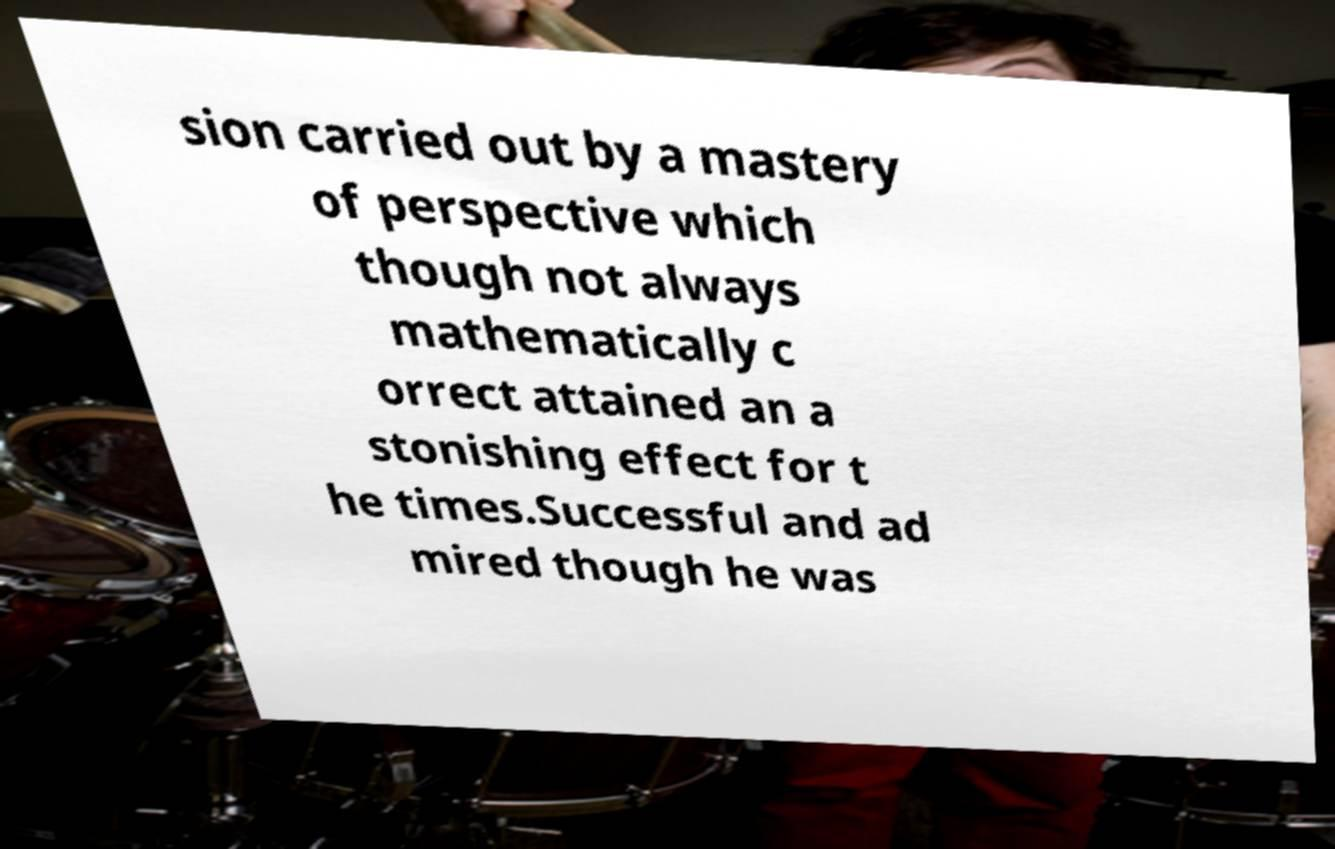I need the written content from this picture converted into text. Can you do that? sion carried out by a mastery of perspective which though not always mathematically c orrect attained an a stonishing effect for t he times.Successful and ad mired though he was 